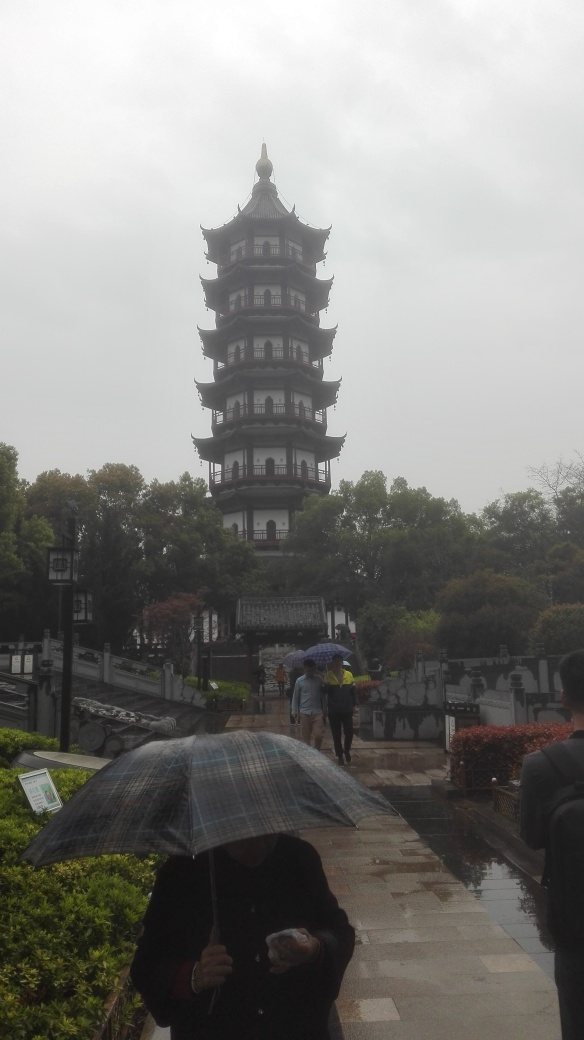Can you describe the atmosphere of this location? The atmosphere conveyed by the image is serene yet lively. The overcast sky and light drizzle create a tranquil mood, while the visitors with umbrellas add a dynamic element as they engage with the site, demonstrating the area's appeal regardless of the weather. 